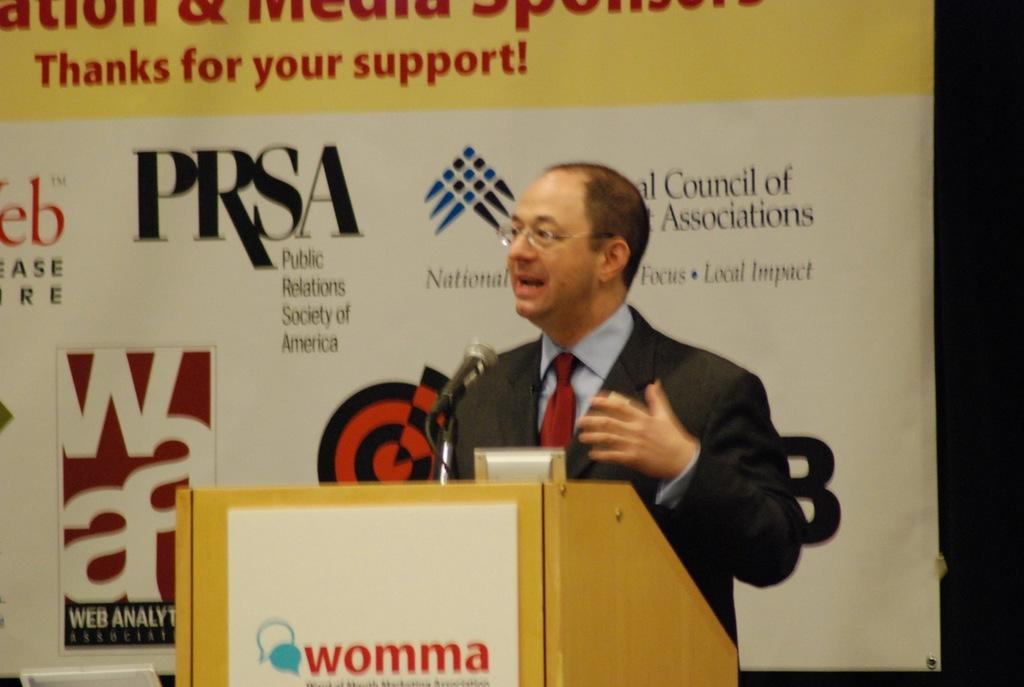How would you summarize this image in a sentence or two? This is the picture of a person who is standing in front of the desk on which there is a mic and behind there is a poster. 